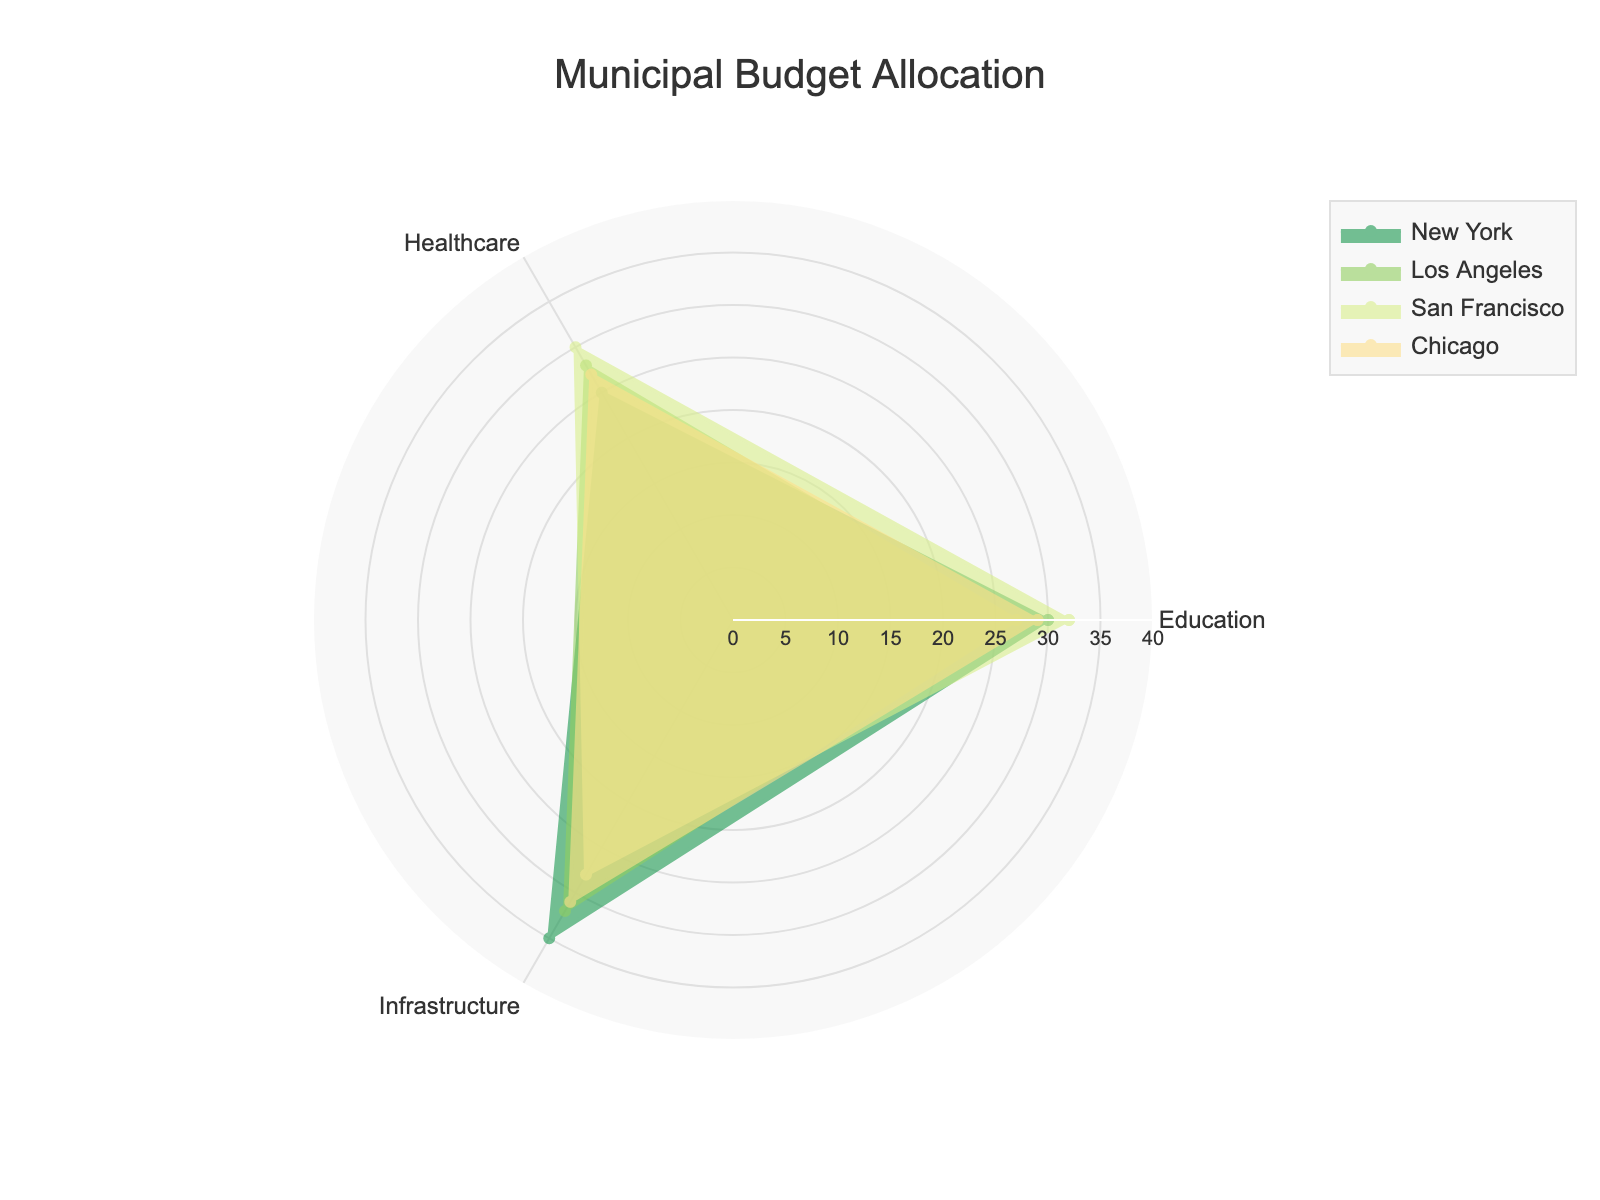Which city allocates the highest percentage of its budget to healthcare? San Francisco has the highest value on the radar chart for the healthcare category, with 30%.
Answer: San Francisco What is the range of percentages for infrastructure allocation among the cities? The range is found by subtracting the smallest percentage from the largest percentage in the infrastructure category. The highest is 35% (New York) and the lowest is 28% (San Francisco), giving a range of 35% - 28% = 7%.
Answer: 7% Which category does Los Angeles allocate the least percentage of its budget to? By observing the radar chart, Los Angeles's smallest budget allocation is for Education, at 27%.
Answer: Education How does the budget allocation for education in Chicago compare to Los Angeles? On the radar chart, Chicago allocates 29% to education, while Los Angeles allocates 27%. Therefore, Chicago allocates 2% more.
Answer: 2% more What is the average budget allocation for infrastructure across all cities? Sum the infrastructure percentages: 35 (NY) + 32 (LA) + 28 (SF) + 31 (Chicago) = 126. Then divide by 4 (number of cities): 126 / 4 = 31.5%.
Answer: 31.5% In which category does New York have a higher budget allocation than both Los Angeles and San Francisco? Examine New York's allocations against Los Angeles and San Francisco. New York's allocation for infrastructure (35%) is higher than both Los Angeles (32%) and San Francisco (28%).
Answer: Infrastructure Which city has the most balanced budget allocation across all three categories? A balanced budget allocation would have values close to each other in each category. Examining the radar chart, Chicago with 29% for Education, 27% for Healthcare, and 31% for Infrastructure appears the most balanced.
Answer: Chicago On average, which category receives the highest budget allocation across all cities? Add the percentages for each category and divide by the number of cities. For Education: (30+27+32+29)/4=29.5%. For Healthcare: (25+28+30+27)/4=27.5%. For Infrastructure: (35+32+28+31)/4=31.5%. Infrastructure has the highest average.
Answer: Infrastructure 